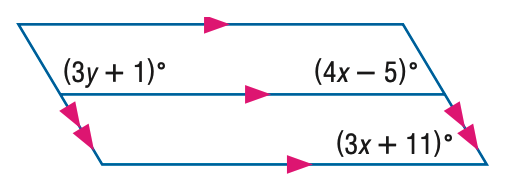Answer the mathemtical geometry problem and directly provide the correct option letter.
Question: Find x in the figure.
Choices: A: 14 B: 15 C: 16 D: 17 C 